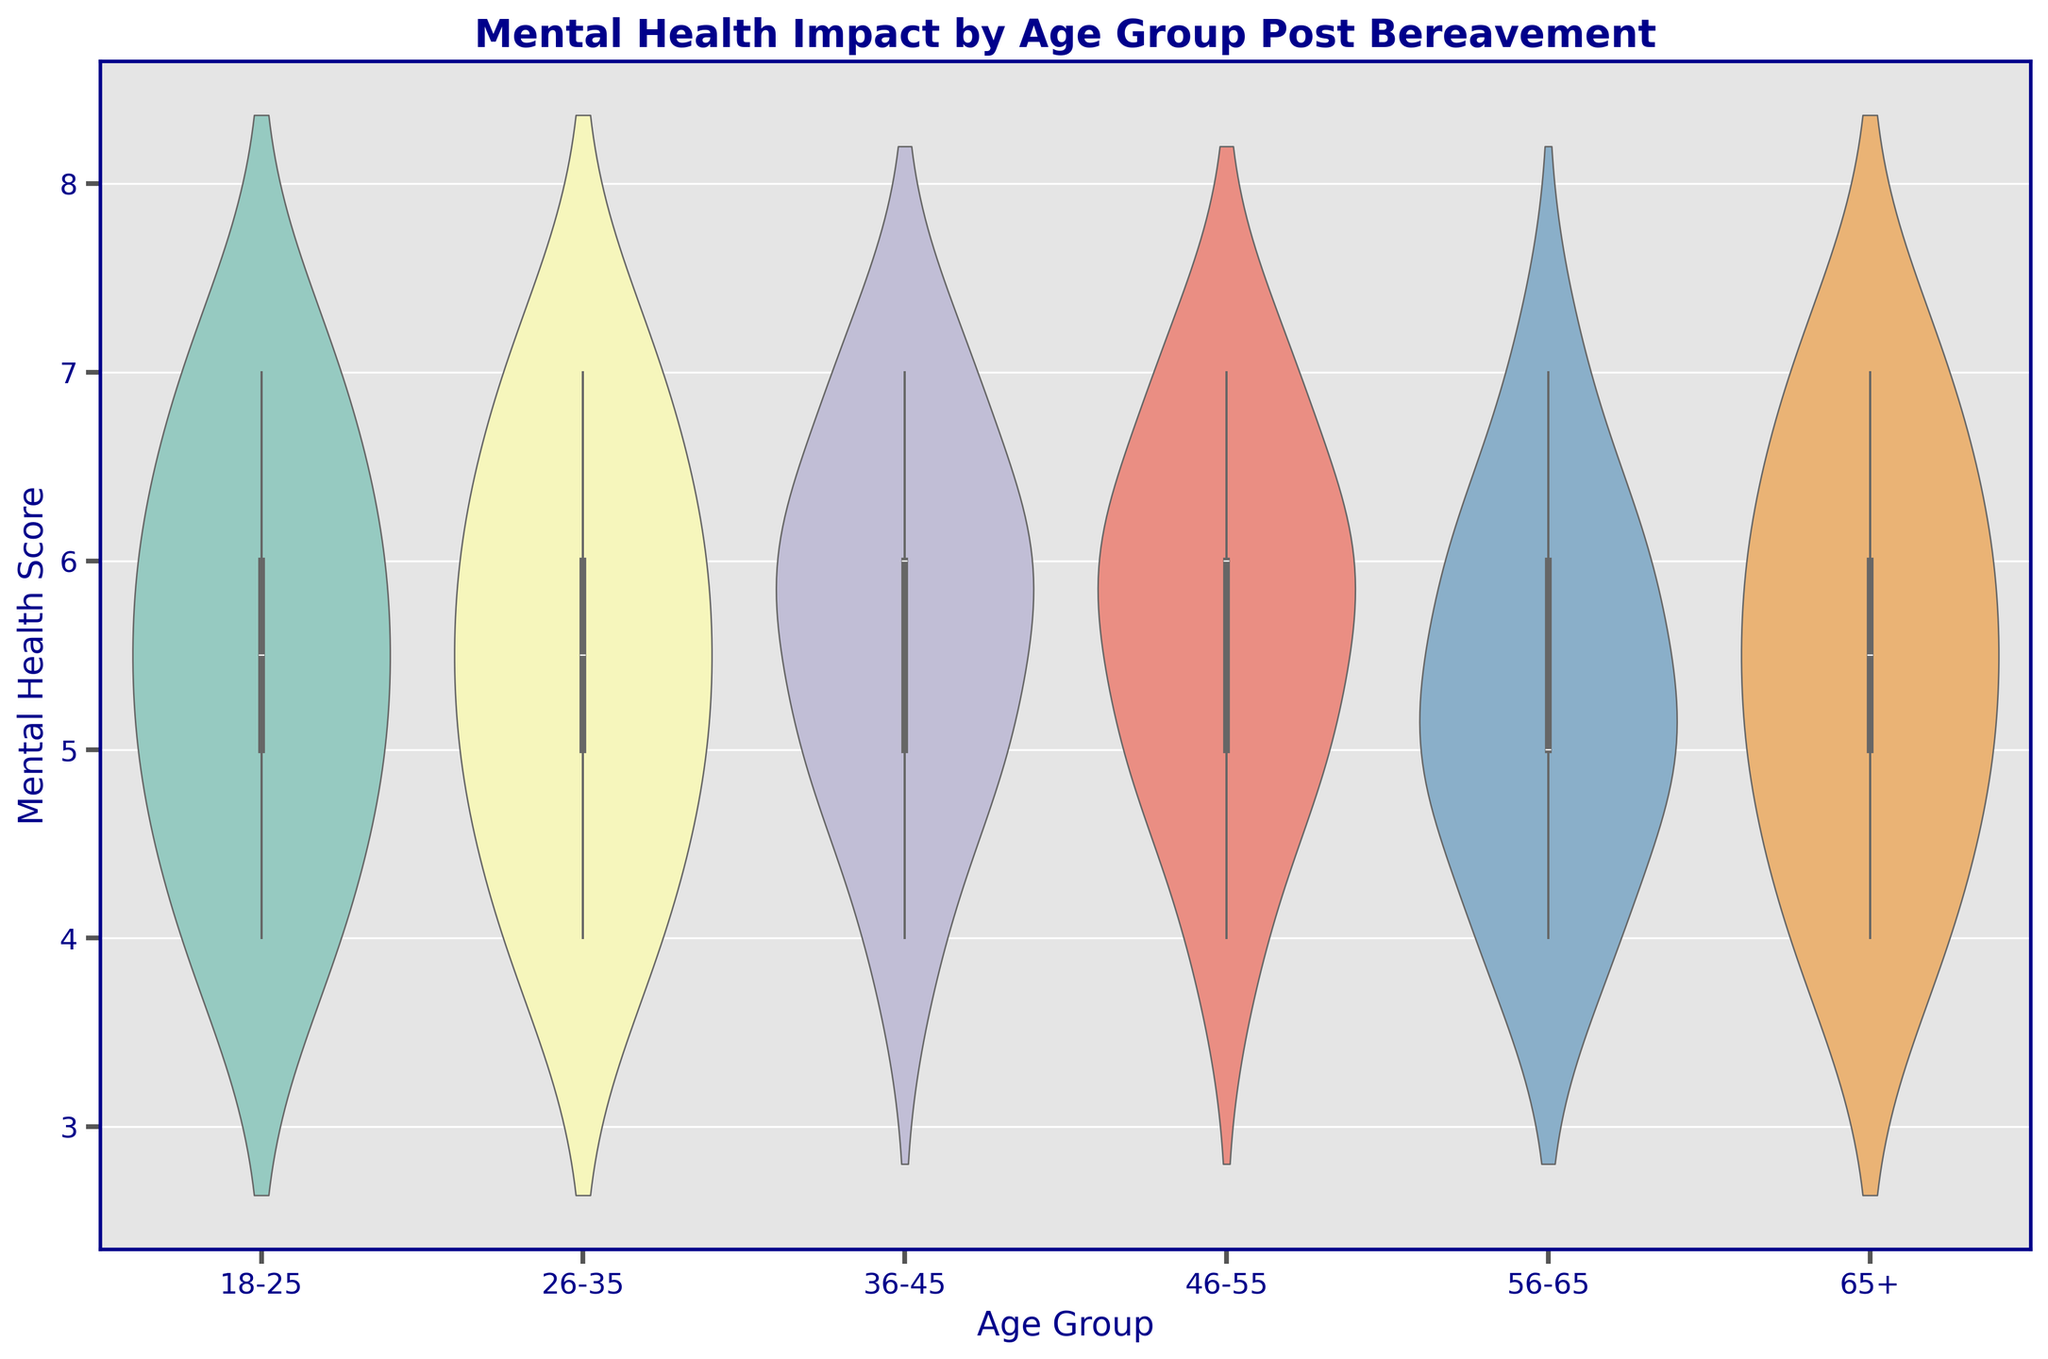What's the median mental health score for the 26-35 age group? The violin plot displays a box plot within it. The median is represented by the line inside the box for each age group. For the 26-35 age group, the median mental health score can be visually identified as the line within the middle of the box.
Answer: 5.5 Which age group has the most variation in mental health scores? The variation in the mental health scores can be judged by the width of the violin plot for each age group. The wider the plot, the more variation there is. By comparing the widths, the age group with the largest width is the 18-25 group.
Answer: 18-25 What is the range of mental health scores for the 46-55 age group? The range is calculated by subtracting the smallest value from the largest value in the data set for that age group. By inspecting the plot, scores for the 46-55 age group range from 4 to 7. Therefore, the range is 7 - 4.
Answer: 3 Which age group has the highest upper quartile for mental health scores? The upper quartile is represented by the top edge of the box in the box plot. The 36-45 age group appears to have the highest top edge, representing the highest upper quartile.
Answer: 36-45 Are there any age groups where the mental health scores are symmetrically distributed? A symmetrical distribution would look similar on both sides of the line through the center of the violin plot. The 46-55 age group demonstrates a symmetrical shape around the center.
Answer: 46-55 How does the median mental health score for the 56-65 age group compare to the 18-25 age group? The median for each age group is represented by the line inside the box in the box plot. By comparing these lines, the median for the 56-65 age group is lower than that of the 18-25 age group.
Answer: Lower Which age groups have mental health scores that extend to a value of 4? The spans of each violin plot illustrate the range of values present. Observing these spans, the age groups where the scores extend down to 4 are 18-25, 26-35, 46-55, 56-65, and 65+.
Answer: 18-25, 26-35, 46-55, 56-65, 65+ What is the most common mental health score range for the 65+ age group? The densest part of the violin plot indicates the most common scores, which is the widest segment. For the 65+ age group, the widest part falls between the scores of 5 and 6.
Answer: 5-6 